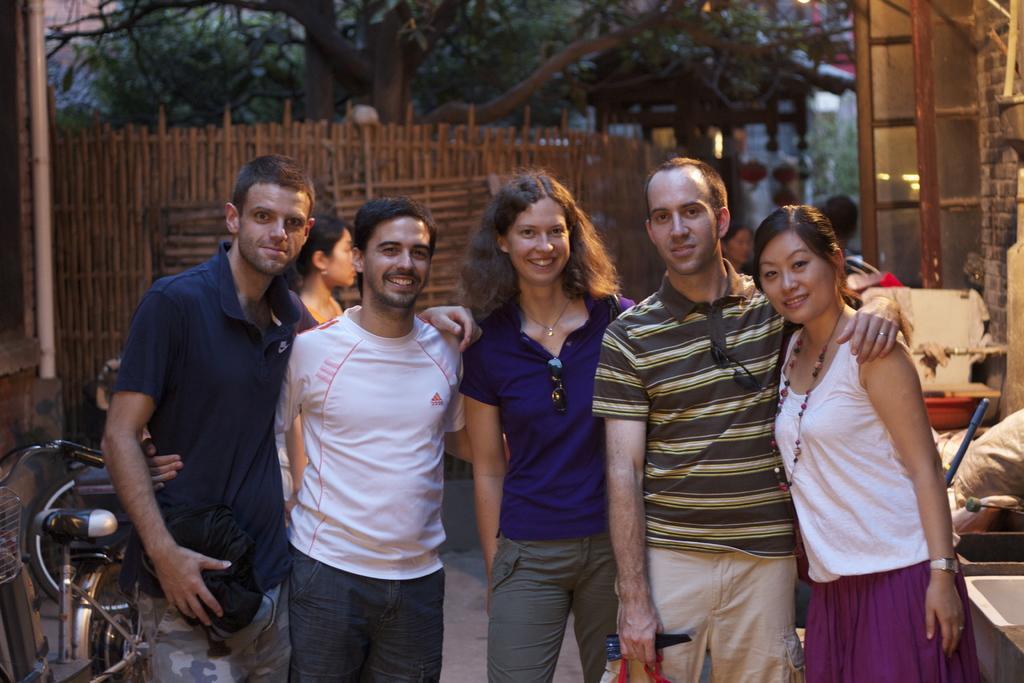Please provide a concise description of this image. In this image we can see the people standing. And we can see the bicycle. And we can see the wooden fence. And we can see the pipelines. And we can see the trees. 